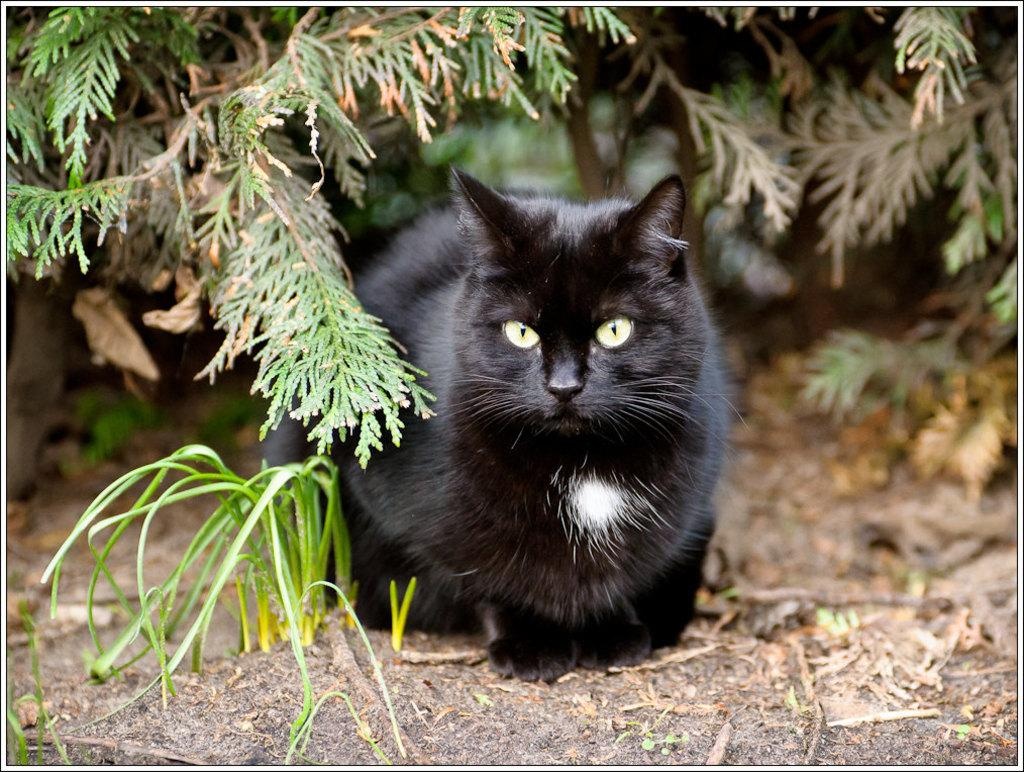What is the main subject in the center of the image? There is a cat in the center of the image. What type of vegetation is visible at the bottom of the image? There is grass at the bottom of the image. What can be seen in the background of the image? There are plants in the background of the image. What type of music is the cat playing in the image? There is no music or instrument present in the image, so the cat is not playing any music. 